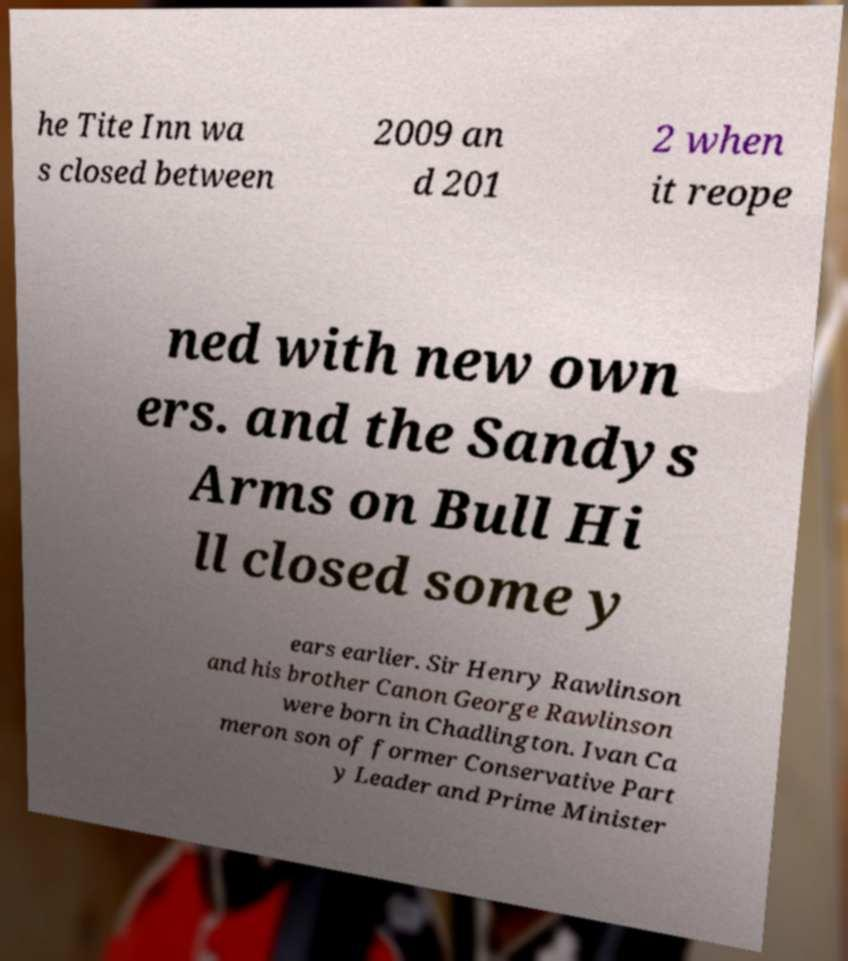Could you extract and type out the text from this image? he Tite Inn wa s closed between 2009 an d 201 2 when it reope ned with new own ers. and the Sandys Arms on Bull Hi ll closed some y ears earlier. Sir Henry Rawlinson and his brother Canon George Rawlinson were born in Chadlington. Ivan Ca meron son of former Conservative Part y Leader and Prime Minister 